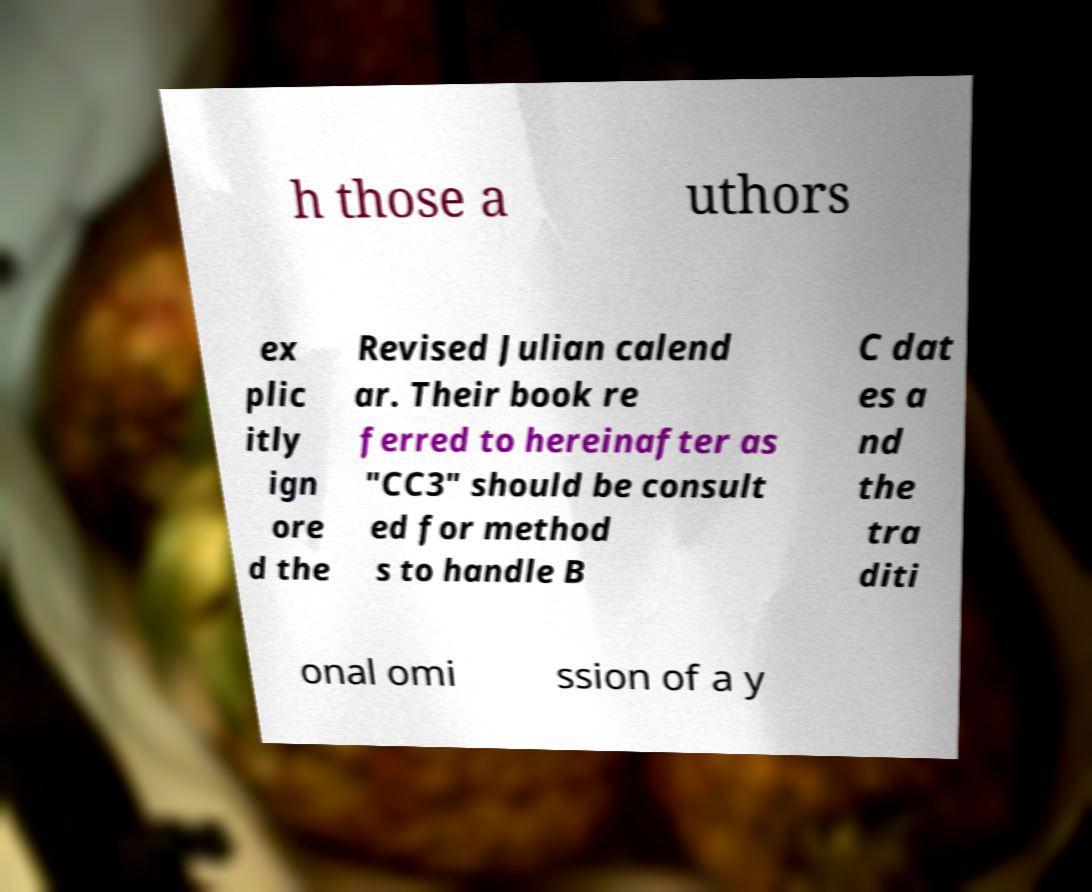Could you assist in decoding the text presented in this image and type it out clearly? h those a uthors ex plic itly ign ore d the Revised Julian calend ar. Their book re ferred to hereinafter as "CC3" should be consult ed for method s to handle B C dat es a nd the tra diti onal omi ssion of a y 